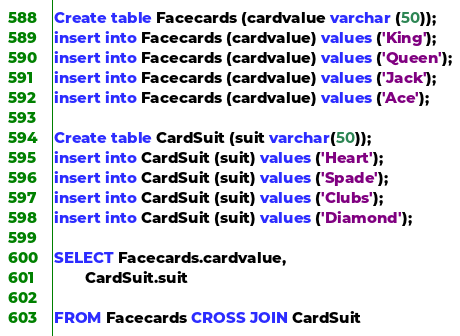Convert code to text. <code><loc_0><loc_0><loc_500><loc_500><_SQL_>Create table Facecards (cardvalue varchar (50)); 
insert into Facecards (cardvalue) values ('King');
insert into Facecards (cardvalue) values ('Queen');
insert into Facecards (cardvalue) values ('Jack');
insert into Facecards (cardvalue) values ('Ace');

Create table CardSuit (suit varchar(50));
insert into CardSuit (suit) values ('Heart');
insert into CardSuit (suit) values ('Spade');
insert into CardSuit (suit) values ('Clubs');
insert into CardSuit (suit) values ('Diamond');

SELECT Facecards.cardvalue,
       CardSuit.suit

FROM Facecards CROSS JOIN CardSuit
</code> 